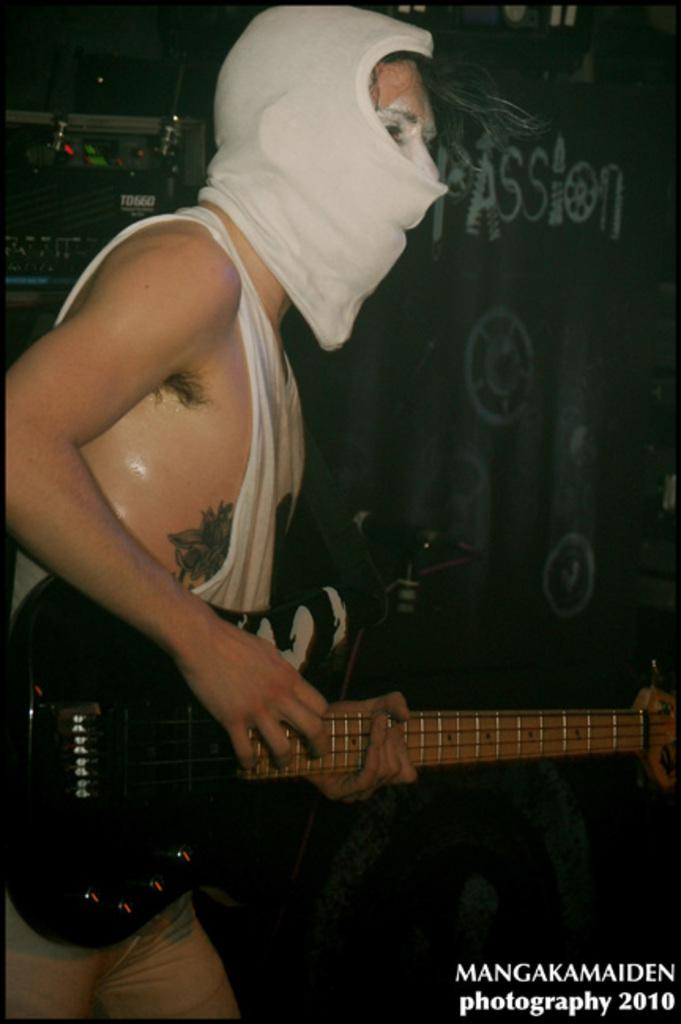What is the main subject of the image? There is a person in the image. What is the person doing in the image? The person is standing and playing a guitar. What can be seen in the background of the image? There is a wall in the background of the image. What type of steel is being used to hold the guitar in the image? There is no steel present in the image, and the guitar is being held by the person playing it. Can you see a hook attached to the wall in the image? There is no hook visible in the image; only the wall can be seen in the background. 